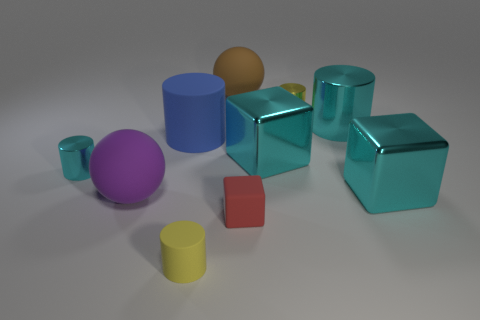Subtract all blue cylinders. How many cylinders are left? 4 Subtract all large cyan metal cylinders. How many cylinders are left? 4 Subtract all brown cylinders. Subtract all yellow balls. How many cylinders are left? 5 Subtract all balls. How many objects are left? 8 Subtract all yellow rubber cylinders. Subtract all tiny blocks. How many objects are left? 8 Add 5 cyan cylinders. How many cyan cylinders are left? 7 Add 7 big cyan metal cylinders. How many big cyan metal cylinders exist? 8 Subtract 0 purple blocks. How many objects are left? 10 